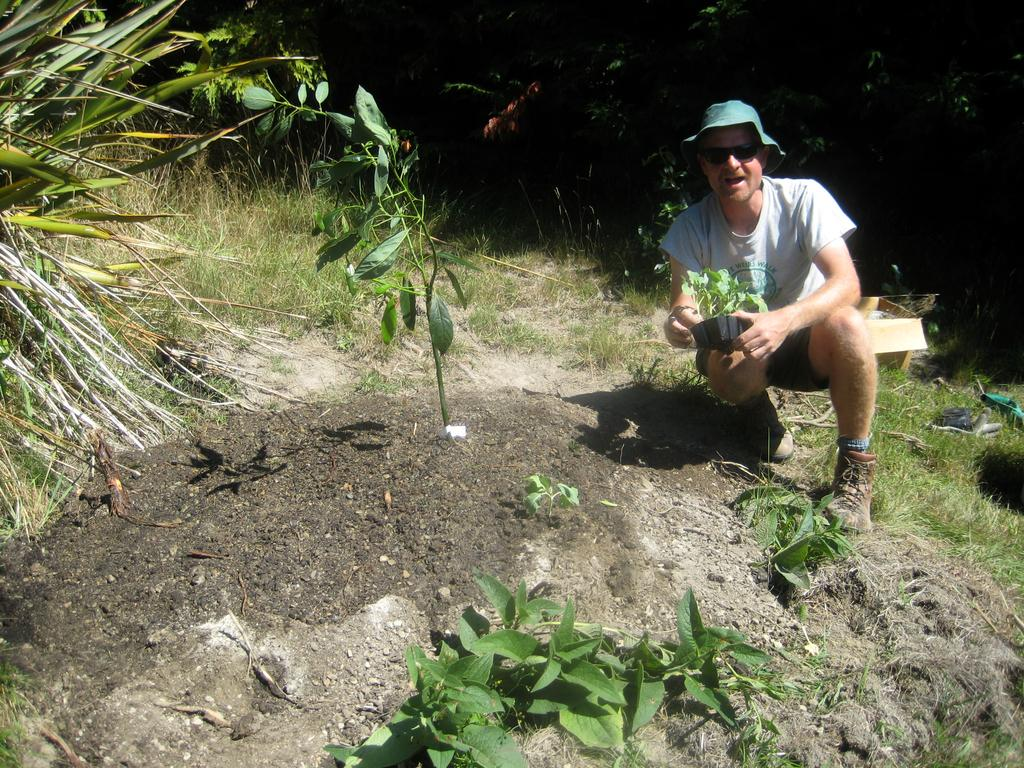Who is present in the image? There is a person in the image. What is the person wearing on their head? The person is wearing a hat. What is the person holding in the image? The person is holding a plant with a pot. What type of vegetation can be seen in the image? There is grass visible in the image, and there are other plants as well. What type of vessel is the person using to cook in the image? There is no vessel or cooking activity present in the image. Can you describe the train that is passing by in the image? There is no train visible in the image. 